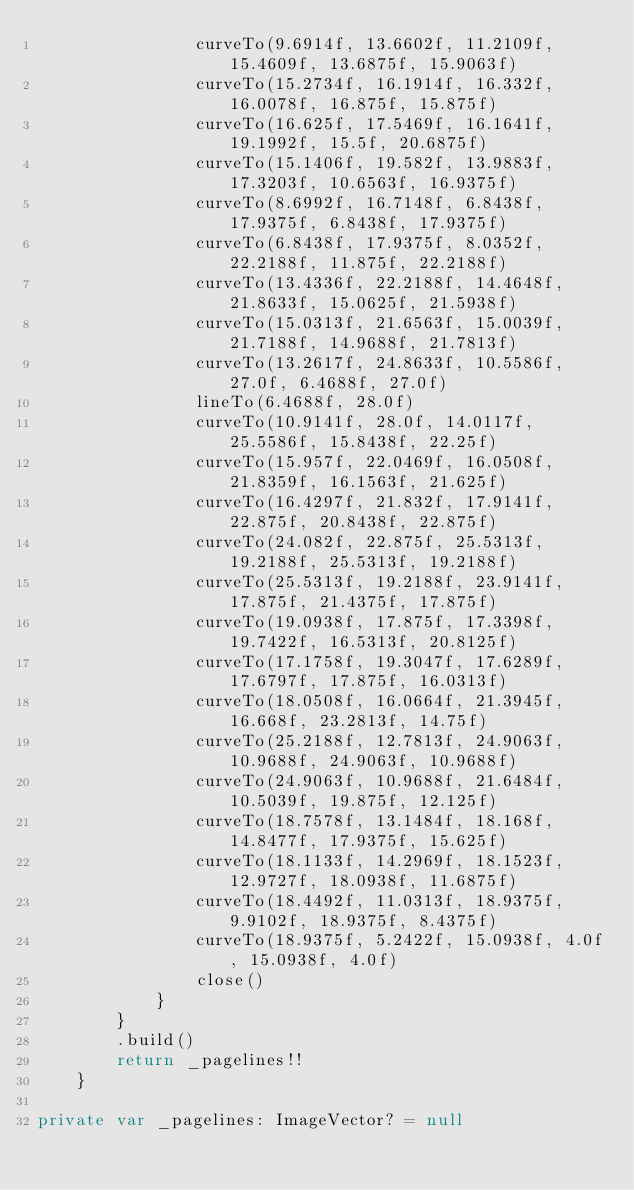<code> <loc_0><loc_0><loc_500><loc_500><_Kotlin_>                curveTo(9.6914f, 13.6602f, 11.2109f, 15.4609f, 13.6875f, 15.9063f)
                curveTo(15.2734f, 16.1914f, 16.332f, 16.0078f, 16.875f, 15.875f)
                curveTo(16.625f, 17.5469f, 16.1641f, 19.1992f, 15.5f, 20.6875f)
                curveTo(15.1406f, 19.582f, 13.9883f, 17.3203f, 10.6563f, 16.9375f)
                curveTo(8.6992f, 16.7148f, 6.8438f, 17.9375f, 6.8438f, 17.9375f)
                curveTo(6.8438f, 17.9375f, 8.0352f, 22.2188f, 11.875f, 22.2188f)
                curveTo(13.4336f, 22.2188f, 14.4648f, 21.8633f, 15.0625f, 21.5938f)
                curveTo(15.0313f, 21.6563f, 15.0039f, 21.7188f, 14.9688f, 21.7813f)
                curveTo(13.2617f, 24.8633f, 10.5586f, 27.0f, 6.4688f, 27.0f)
                lineTo(6.4688f, 28.0f)
                curveTo(10.9141f, 28.0f, 14.0117f, 25.5586f, 15.8438f, 22.25f)
                curveTo(15.957f, 22.0469f, 16.0508f, 21.8359f, 16.1563f, 21.625f)
                curveTo(16.4297f, 21.832f, 17.9141f, 22.875f, 20.8438f, 22.875f)
                curveTo(24.082f, 22.875f, 25.5313f, 19.2188f, 25.5313f, 19.2188f)
                curveTo(25.5313f, 19.2188f, 23.9141f, 17.875f, 21.4375f, 17.875f)
                curveTo(19.0938f, 17.875f, 17.3398f, 19.7422f, 16.5313f, 20.8125f)
                curveTo(17.1758f, 19.3047f, 17.6289f, 17.6797f, 17.875f, 16.0313f)
                curveTo(18.0508f, 16.0664f, 21.3945f, 16.668f, 23.2813f, 14.75f)
                curveTo(25.2188f, 12.7813f, 24.9063f, 10.9688f, 24.9063f, 10.9688f)
                curveTo(24.9063f, 10.9688f, 21.6484f, 10.5039f, 19.875f, 12.125f)
                curveTo(18.7578f, 13.1484f, 18.168f, 14.8477f, 17.9375f, 15.625f)
                curveTo(18.1133f, 14.2969f, 18.1523f, 12.9727f, 18.0938f, 11.6875f)
                curveTo(18.4492f, 11.0313f, 18.9375f, 9.9102f, 18.9375f, 8.4375f)
                curveTo(18.9375f, 5.2422f, 15.0938f, 4.0f, 15.0938f, 4.0f)
                close()
            }
        }
        .build()
        return _pagelines!!
    }

private var _pagelines: ImageVector? = null
</code> 